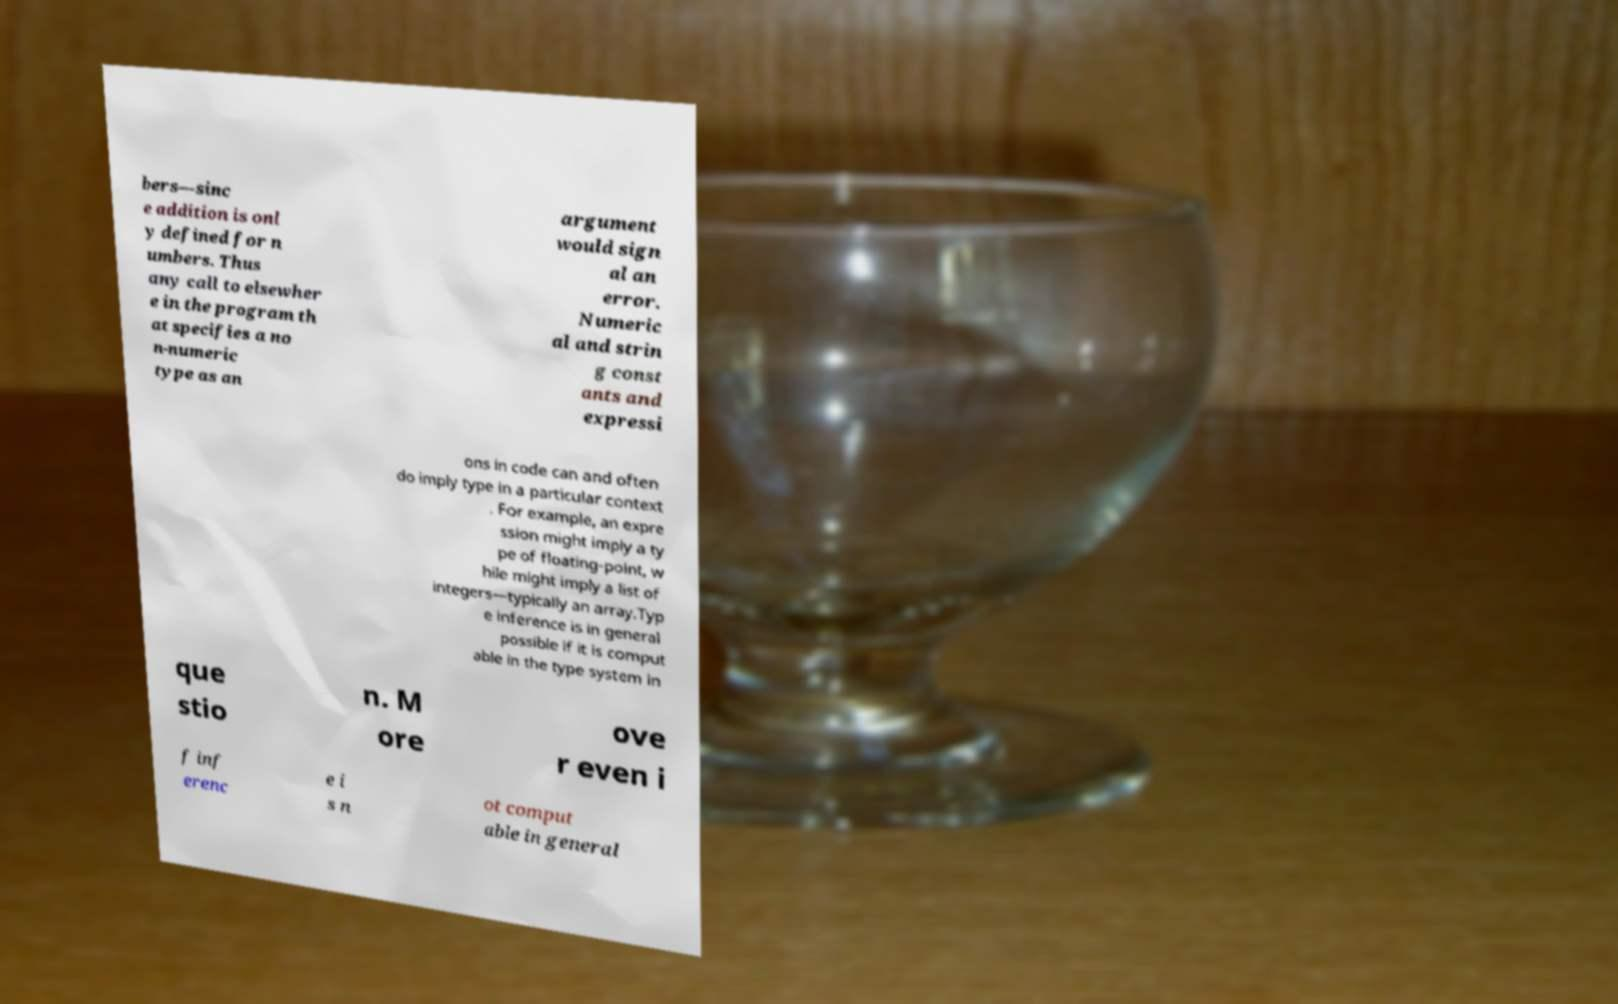What messages or text are displayed in this image? I need them in a readable, typed format. bers—sinc e addition is onl y defined for n umbers. Thus any call to elsewher e in the program th at specifies a no n-numeric type as an argument would sign al an error. Numeric al and strin g const ants and expressi ons in code can and often do imply type in a particular context . For example, an expre ssion might imply a ty pe of floating-point, w hile might imply a list of integers—typically an array.Typ e inference is in general possible if it is comput able in the type system in que stio n. M ore ove r even i f inf erenc e i s n ot comput able in general 